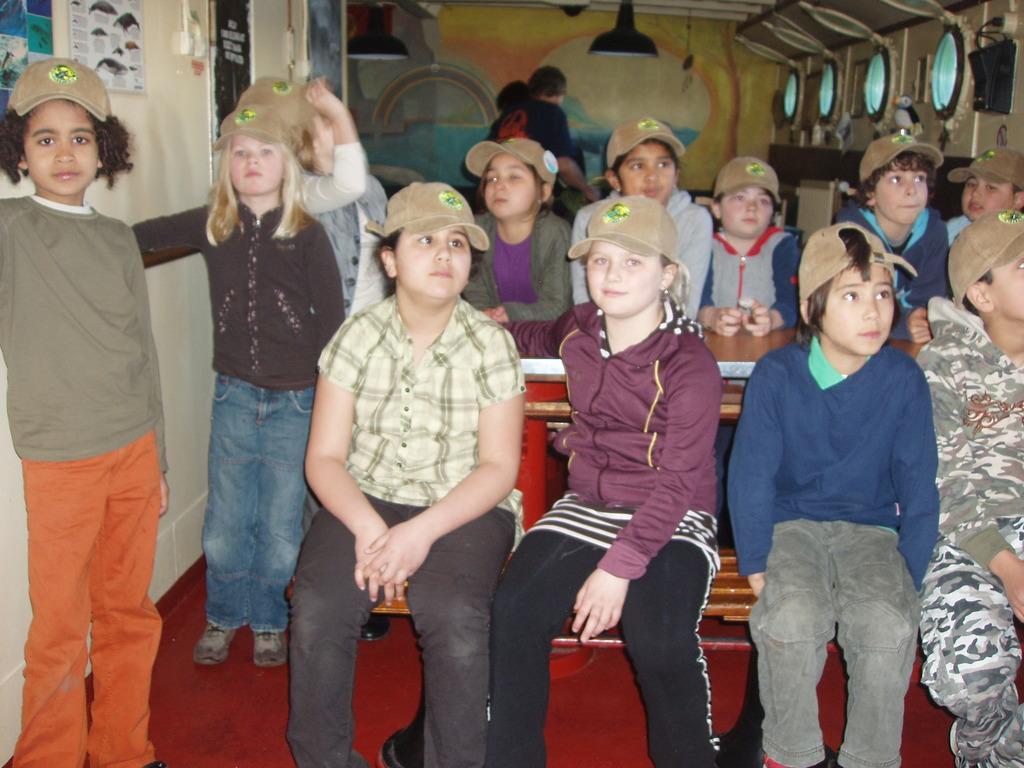How would you summarize this image in a sentence or two? In this picture we can see a group of small boys and girls sitting on the benches, smiling and giving a pose to the camera. Behind we can see painted wall and hanging lights. 